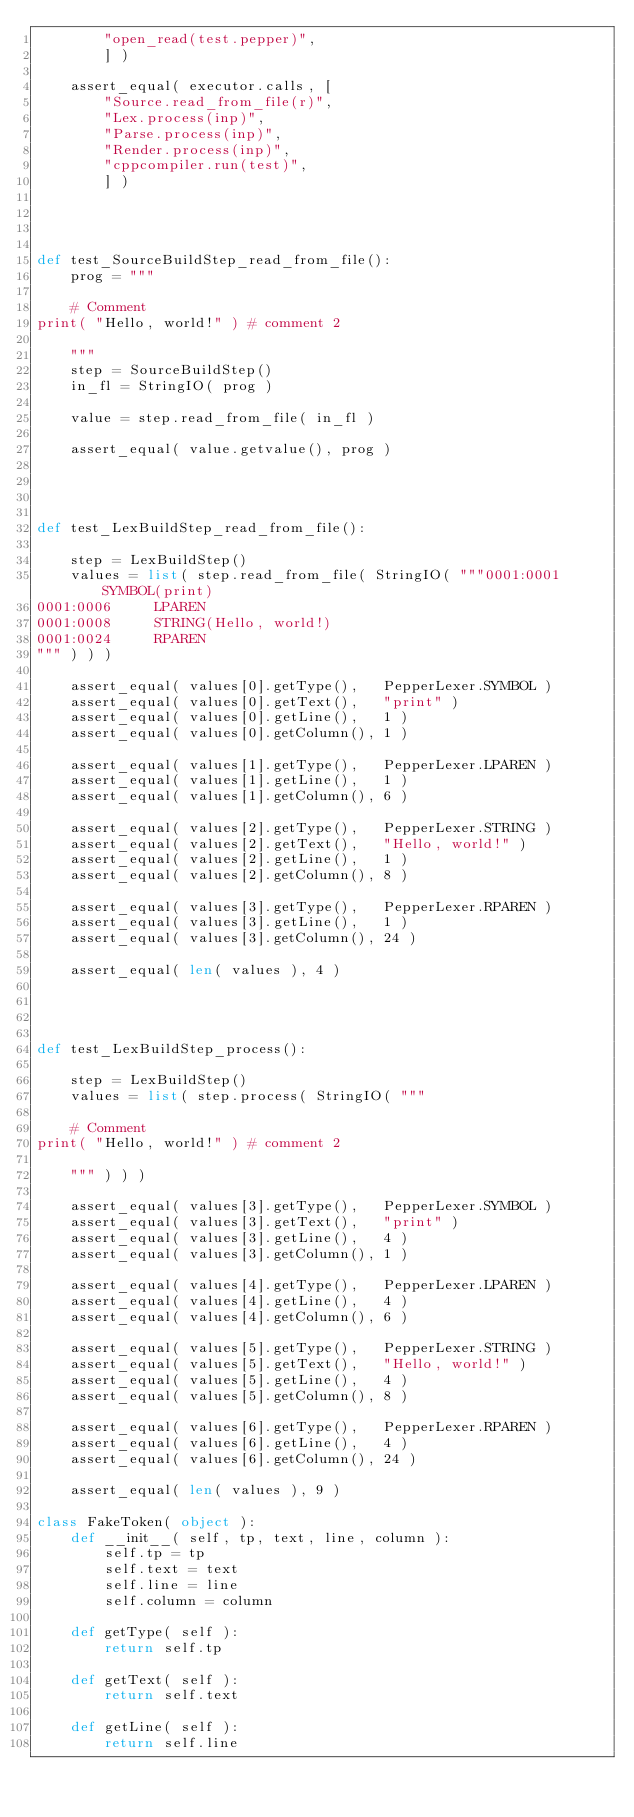Convert code to text. <code><loc_0><loc_0><loc_500><loc_500><_Python_>        "open_read(test.pepper)",
        ] )

    assert_equal( executor.calls, [
        "Source.read_from_file(r)",
        "Lex.process(inp)",
        "Parse.process(inp)",
        "Render.process(inp)",
        "cppcompiler.run(test)",
        ] )




def test_SourceBuildStep_read_from_file():
    prog = """

    # Comment
print( "Hello, world!" ) # comment 2

    """
    step = SourceBuildStep()
    in_fl = StringIO( prog )

    value = step.read_from_file( in_fl )

    assert_equal( value.getvalue(), prog )




def test_LexBuildStep_read_from_file():

    step = LexBuildStep()
    values = list( step.read_from_file( StringIO( """0001:0001     SYMBOL(print)
0001:0006     LPAREN
0001:0008     STRING(Hello, world!)
0001:0024     RPAREN
""" ) ) )

    assert_equal( values[0].getType(),   PepperLexer.SYMBOL )
    assert_equal( values[0].getText(),   "print" )
    assert_equal( values[0].getLine(),   1 )
    assert_equal( values[0].getColumn(), 1 )

    assert_equal( values[1].getType(),   PepperLexer.LPAREN )
    assert_equal( values[1].getLine(),   1 )
    assert_equal( values[1].getColumn(), 6 )

    assert_equal( values[2].getType(),   PepperLexer.STRING )
    assert_equal( values[2].getText(),   "Hello, world!" )
    assert_equal( values[2].getLine(),   1 )
    assert_equal( values[2].getColumn(), 8 )

    assert_equal( values[3].getType(),   PepperLexer.RPAREN )
    assert_equal( values[3].getLine(),   1 )
    assert_equal( values[3].getColumn(), 24 )

    assert_equal( len( values ), 4 )




def test_LexBuildStep_process():

    step = LexBuildStep()
    values = list( step.process( StringIO( """

    # Comment
print( "Hello, world!" ) # comment 2

    """ ) ) )

    assert_equal( values[3].getType(),   PepperLexer.SYMBOL )
    assert_equal( values[3].getText(),   "print" )
    assert_equal( values[3].getLine(),   4 )
    assert_equal( values[3].getColumn(), 1 )

    assert_equal( values[4].getType(),   PepperLexer.LPAREN )
    assert_equal( values[4].getLine(),   4 )
    assert_equal( values[4].getColumn(), 6 )

    assert_equal( values[5].getType(),   PepperLexer.STRING )
    assert_equal( values[5].getText(),   "Hello, world!" )
    assert_equal( values[5].getLine(),   4 )
    assert_equal( values[5].getColumn(), 8 )

    assert_equal( values[6].getType(),   PepperLexer.RPAREN )
    assert_equal( values[6].getLine(),   4 )
    assert_equal( values[6].getColumn(), 24 )

    assert_equal( len( values ), 9 )

class FakeToken( object ):
    def __init__( self, tp, text, line, column ):
        self.tp = tp
        self.text = text
        self.line = line
        self.column = column

    def getType( self ):
        return self.tp

    def getText( self ):
        return self.text

    def getLine( self ):
        return self.line
</code> 